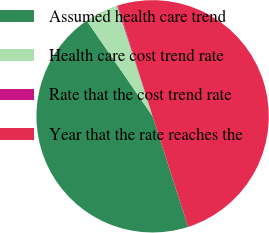<chart> <loc_0><loc_0><loc_500><loc_500><pie_chart><fcel>Assumed health care trend<fcel>Health care cost trend rate<fcel>Rate that the cost trend rate<fcel>Year that the rate reaches the<nl><fcel>45.35%<fcel>4.65%<fcel>0.11%<fcel>49.89%<nl></chart> 